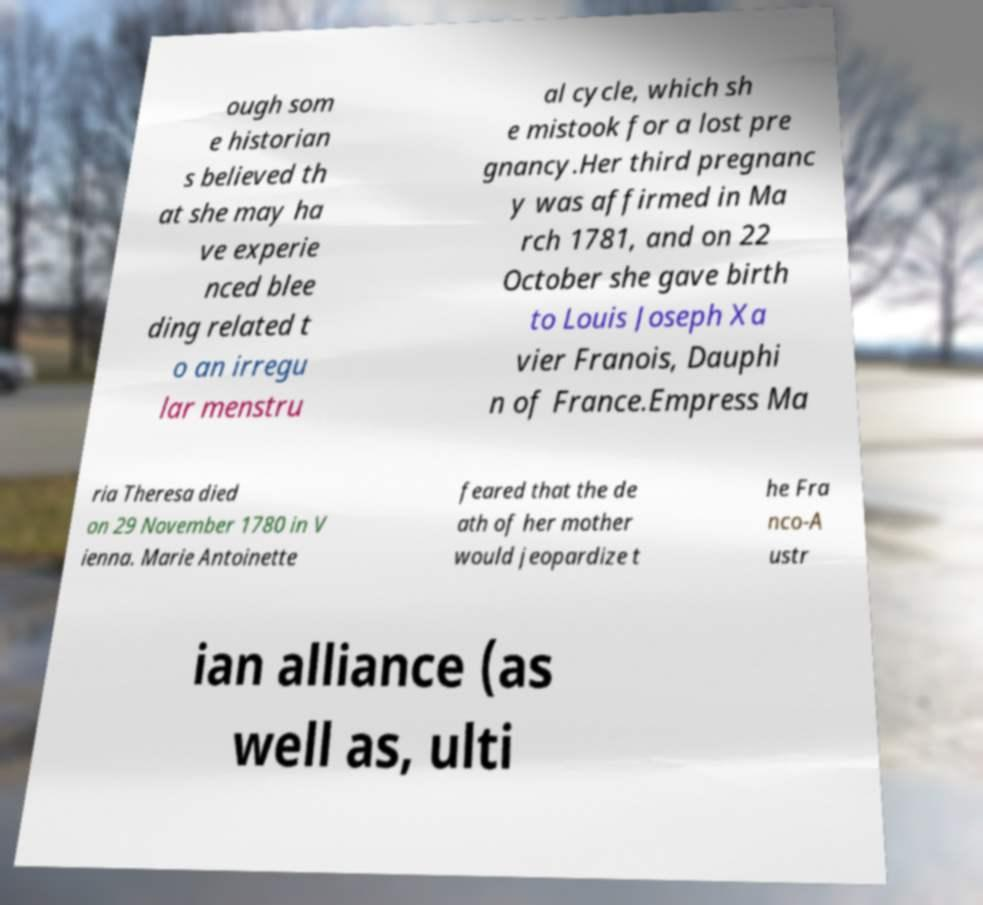Could you extract and type out the text from this image? ough som e historian s believed th at she may ha ve experie nced blee ding related t o an irregu lar menstru al cycle, which sh e mistook for a lost pre gnancy.Her third pregnanc y was affirmed in Ma rch 1781, and on 22 October she gave birth to Louis Joseph Xa vier Franois, Dauphi n of France.Empress Ma ria Theresa died on 29 November 1780 in V ienna. Marie Antoinette feared that the de ath of her mother would jeopardize t he Fra nco-A ustr ian alliance (as well as, ulti 